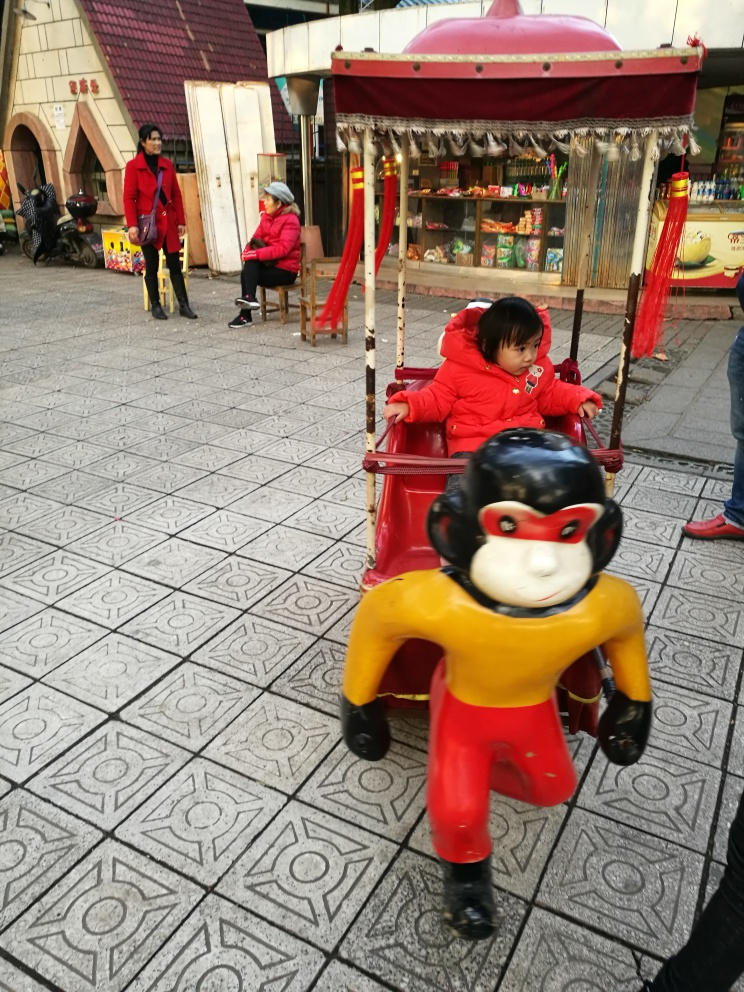Is the composition of the image good? The composition of the image has its strengths, such as capturing a candid moment in a dynamic outdoor setting which gives a sense of everyday life. However, the framing could be improved to focus more on the subjects and reduce the clutter of the background, enhancing the overall impact of the scene. 